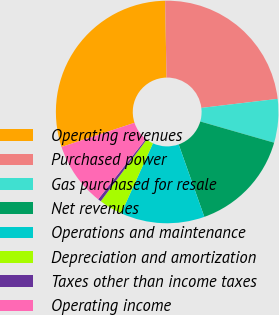<chart> <loc_0><loc_0><loc_500><loc_500><pie_chart><fcel>Operating revenues<fcel>Purchased power<fcel>Gas purchased for resale<fcel>Net revenues<fcel>Operations and maintenance<fcel>Depreciation and amortization<fcel>Taxes other than income taxes<fcel>Operating income<nl><fcel>29.8%<fcel>23.41%<fcel>6.33%<fcel>15.13%<fcel>12.2%<fcel>3.4%<fcel>0.46%<fcel>9.26%<nl></chart> 